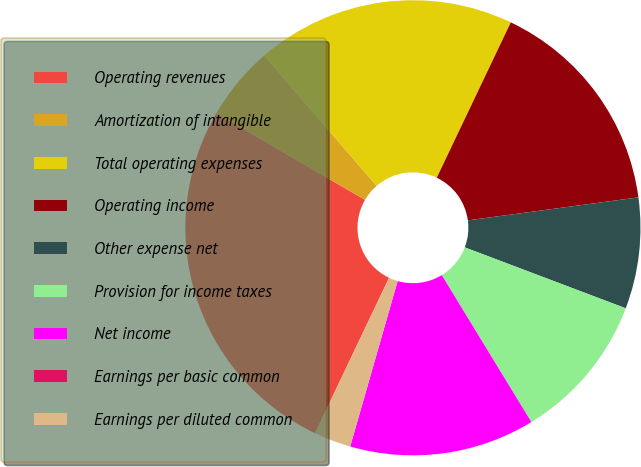Convert chart. <chart><loc_0><loc_0><loc_500><loc_500><pie_chart><fcel>Operating revenues<fcel>Amortization of intangible<fcel>Total operating expenses<fcel>Operating income<fcel>Other expense net<fcel>Provision for income taxes<fcel>Net income<fcel>Earnings per basic common<fcel>Earnings per diluted common<nl><fcel>26.32%<fcel>5.26%<fcel>18.42%<fcel>15.79%<fcel>7.89%<fcel>10.53%<fcel>13.16%<fcel>0.0%<fcel>2.63%<nl></chart> 